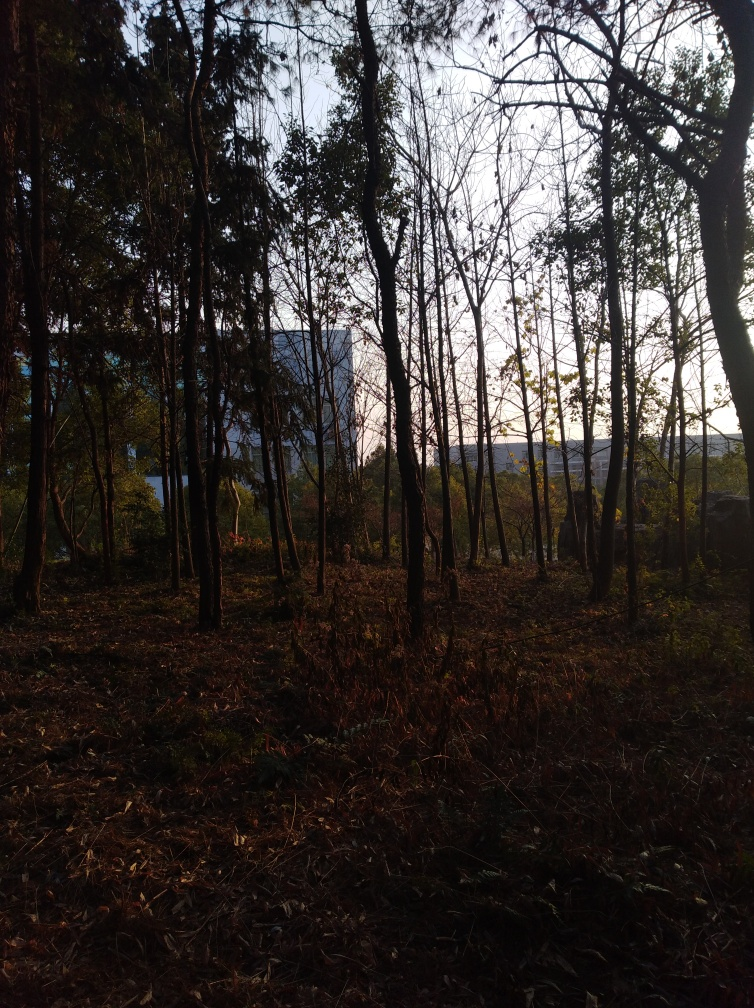Can you identify the type of trees in this forest? Identifying the exact species of trees from this image alone can be challenging without closer details of leaves or bark. However, these trees appear to be tall with slender trunks and a certain sparseness to their branches, which could suggest they could be a variety of trees that are common in temperate forests. To give a more accurate identification, a more detailed image or additional information about the local flora would be needed. 